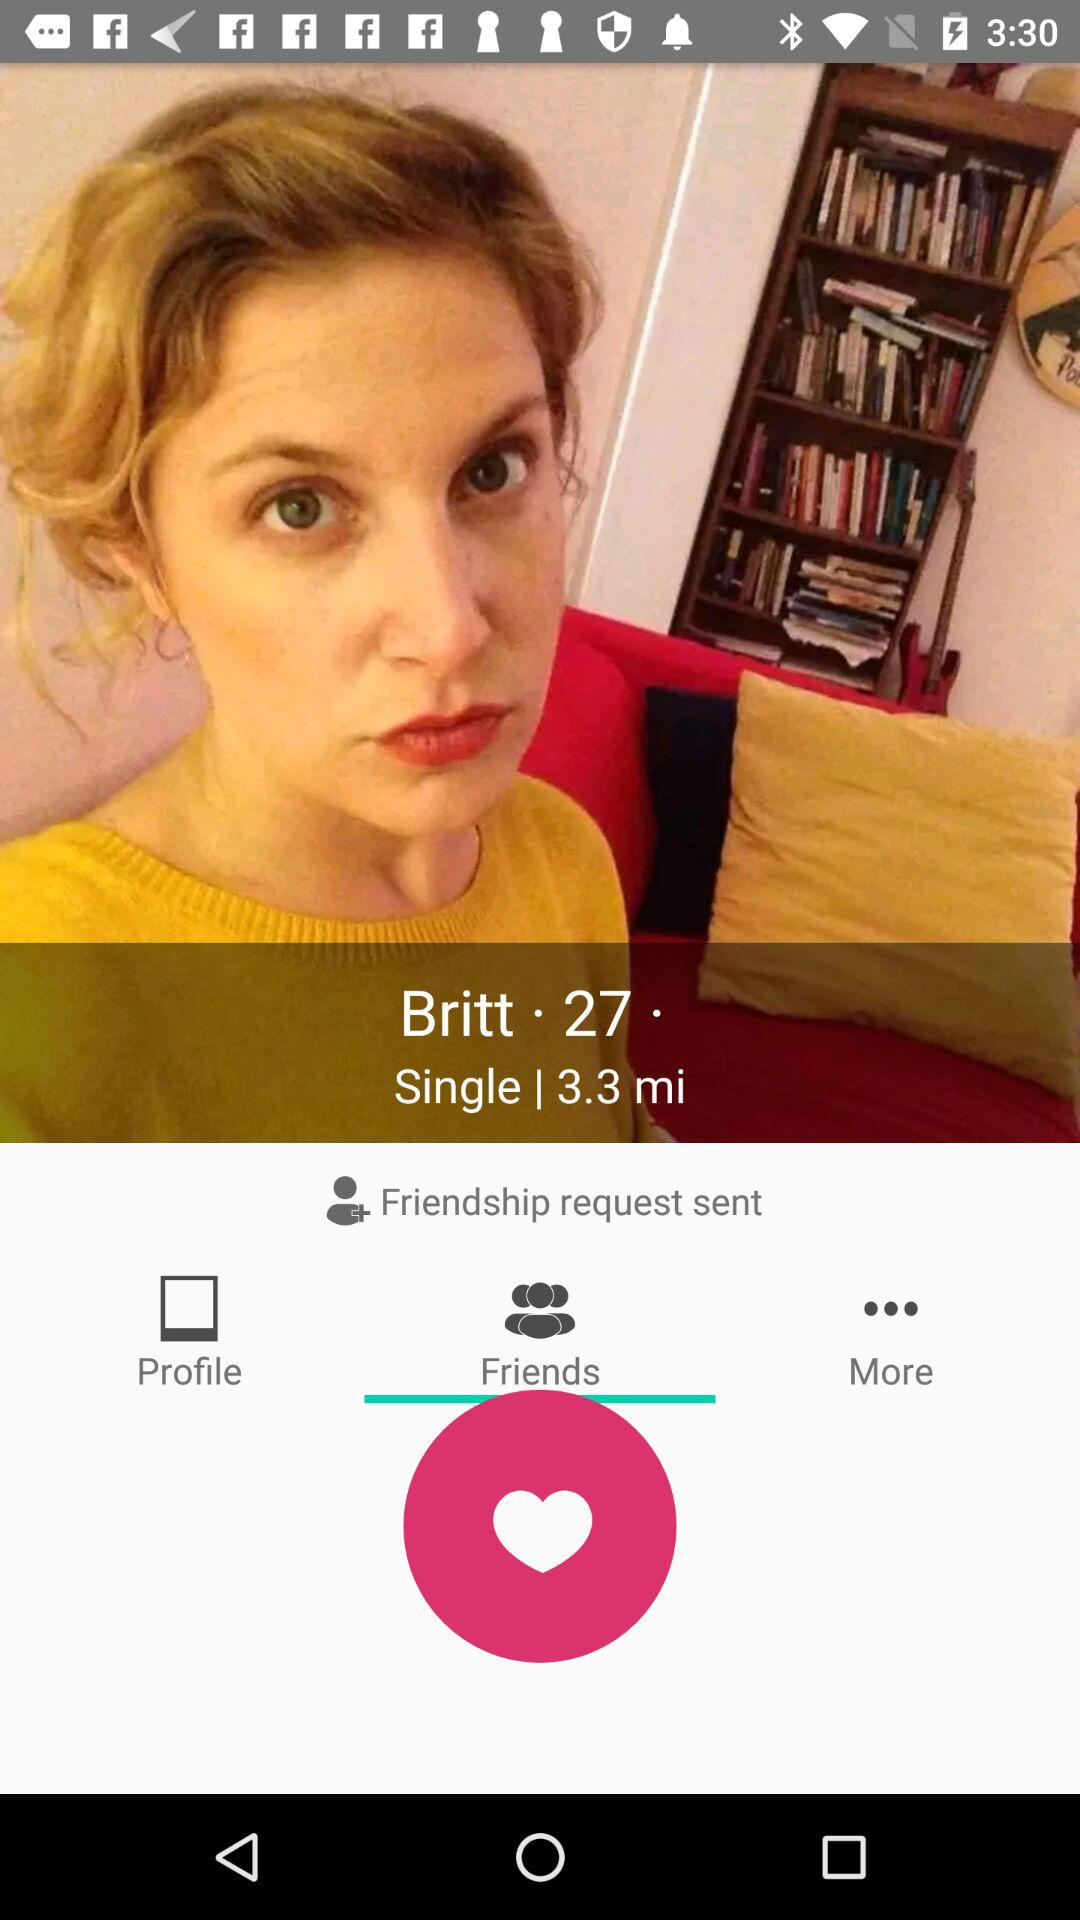What is the age of Britt? The age of Britt is 27. 